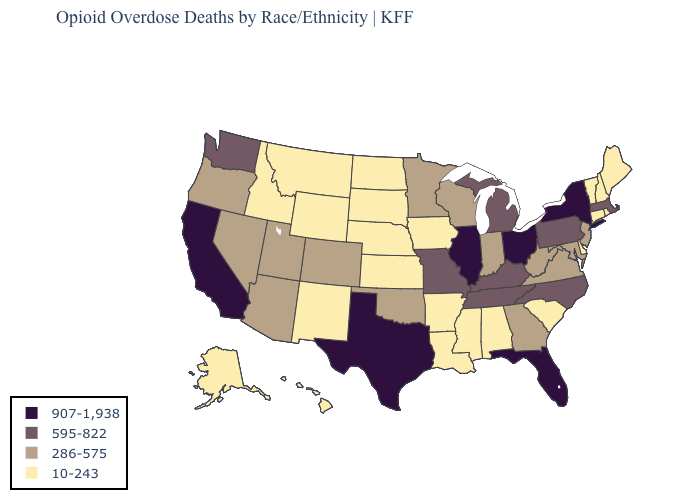What is the highest value in states that border Kansas?
Answer briefly. 595-822. What is the value of Oklahoma?
Answer briefly. 286-575. How many symbols are there in the legend?
Write a very short answer. 4. Does Wyoming have a lower value than Michigan?
Concise answer only. Yes. Which states have the lowest value in the MidWest?
Give a very brief answer. Iowa, Kansas, Nebraska, North Dakota, South Dakota. What is the highest value in states that border Alabama?
Concise answer only. 907-1,938. Which states have the lowest value in the South?
Short answer required. Alabama, Arkansas, Delaware, Louisiana, Mississippi, South Carolina. Name the states that have a value in the range 907-1,938?
Give a very brief answer. California, Florida, Illinois, New York, Ohio, Texas. Among the states that border Maryland , which have the highest value?
Quick response, please. Pennsylvania. What is the value of Illinois?
Concise answer only. 907-1,938. Does Texas have a lower value than Oregon?
Be succinct. No. Name the states that have a value in the range 10-243?
Quick response, please. Alabama, Alaska, Arkansas, Connecticut, Delaware, Hawaii, Idaho, Iowa, Kansas, Louisiana, Maine, Mississippi, Montana, Nebraska, New Hampshire, New Mexico, North Dakota, Rhode Island, South Carolina, South Dakota, Vermont, Wyoming. Name the states that have a value in the range 595-822?
Give a very brief answer. Kentucky, Massachusetts, Michigan, Missouri, North Carolina, Pennsylvania, Tennessee, Washington. What is the value of Delaware?
Write a very short answer. 10-243. What is the lowest value in the USA?
Quick response, please. 10-243. 